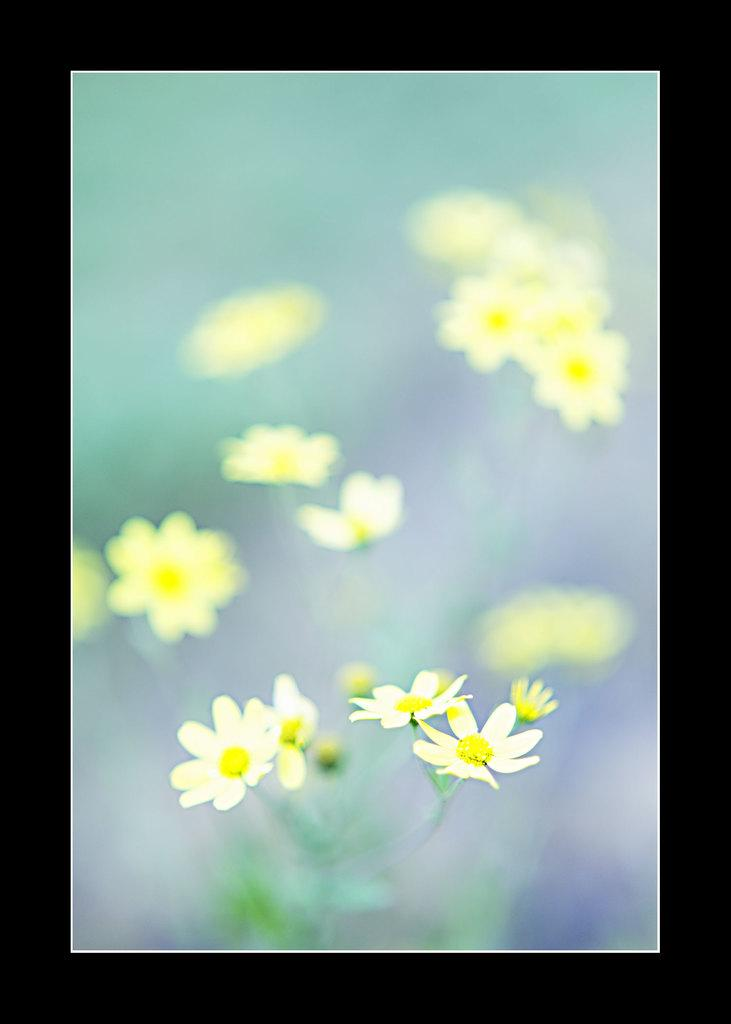What type of objects are present in the image? There are flowers in the image. What colors can be seen on the flowers? The flowers are in white and yellow colors. What colors are present in the background of the image? The background of the image is in green and purple colors. How many trains can be seen in the image? There are no trains present in the image; it features flowers and their colors. 